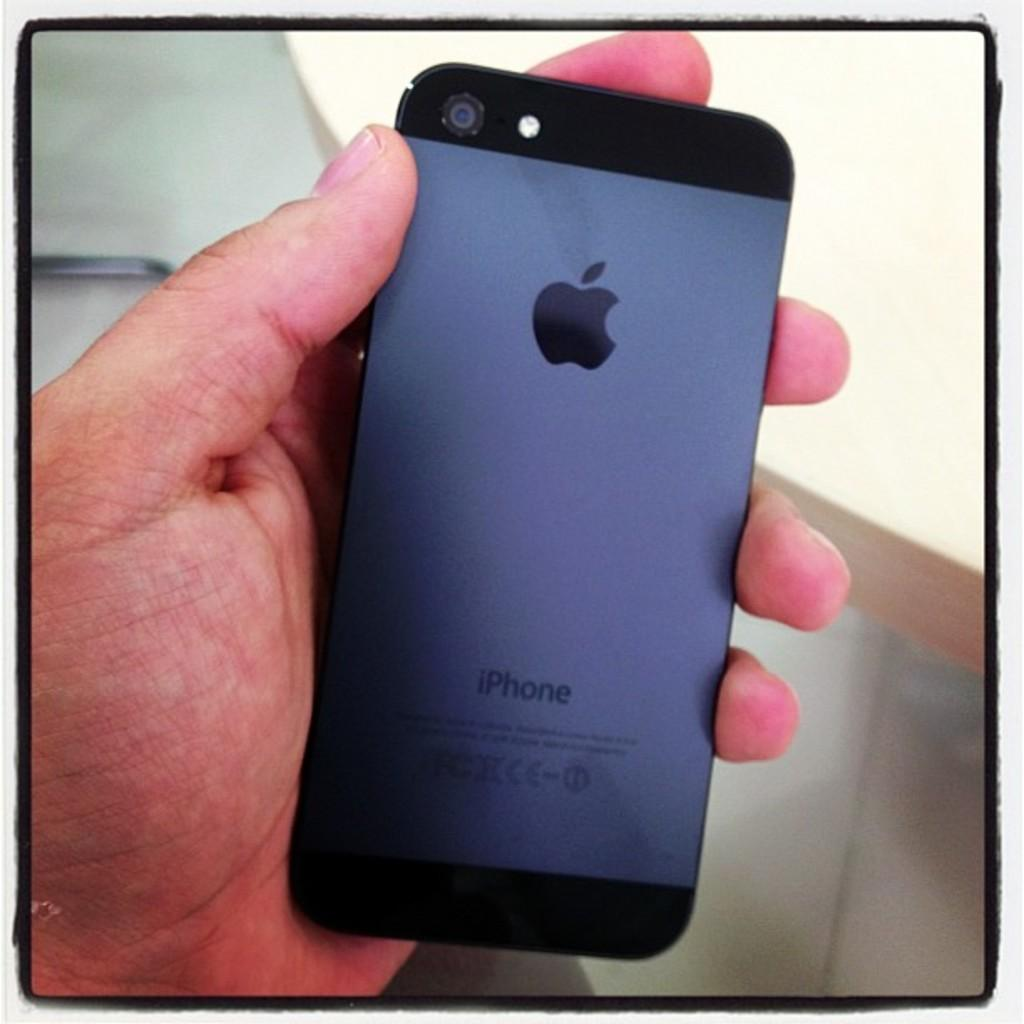What is the main subject of the image? There is a person in the image. What is the person holding in their hand? The person is holding a mobile in their hand. What type of bulb is being used by the queen in the image? There is no queen or bulb present in the image; it features a person holding a mobile. 